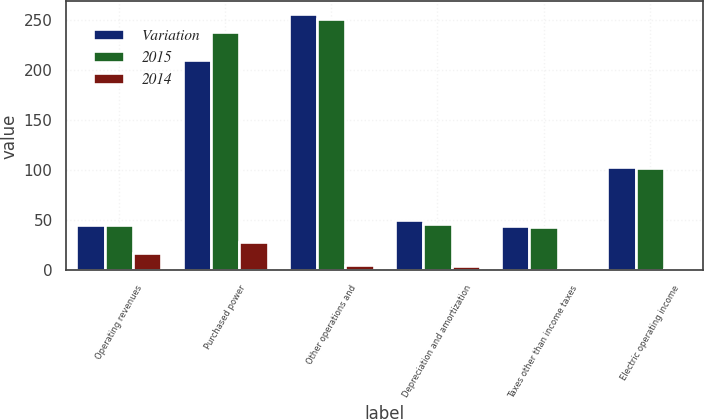<chart> <loc_0><loc_0><loc_500><loc_500><stacked_bar_chart><ecel><fcel>Operating revenues<fcel>Purchased power<fcel>Other operations and<fcel>Depreciation and amortization<fcel>Taxes other than income taxes<fcel>Electric operating income<nl><fcel>Variation<fcel>45<fcel>210<fcel>256<fcel>50<fcel>44<fcel>103<nl><fcel>2015<fcel>45<fcel>238<fcel>251<fcel>46<fcel>43<fcel>102<nl><fcel>2014<fcel>17<fcel>28<fcel>5<fcel>4<fcel>1<fcel>1<nl></chart> 